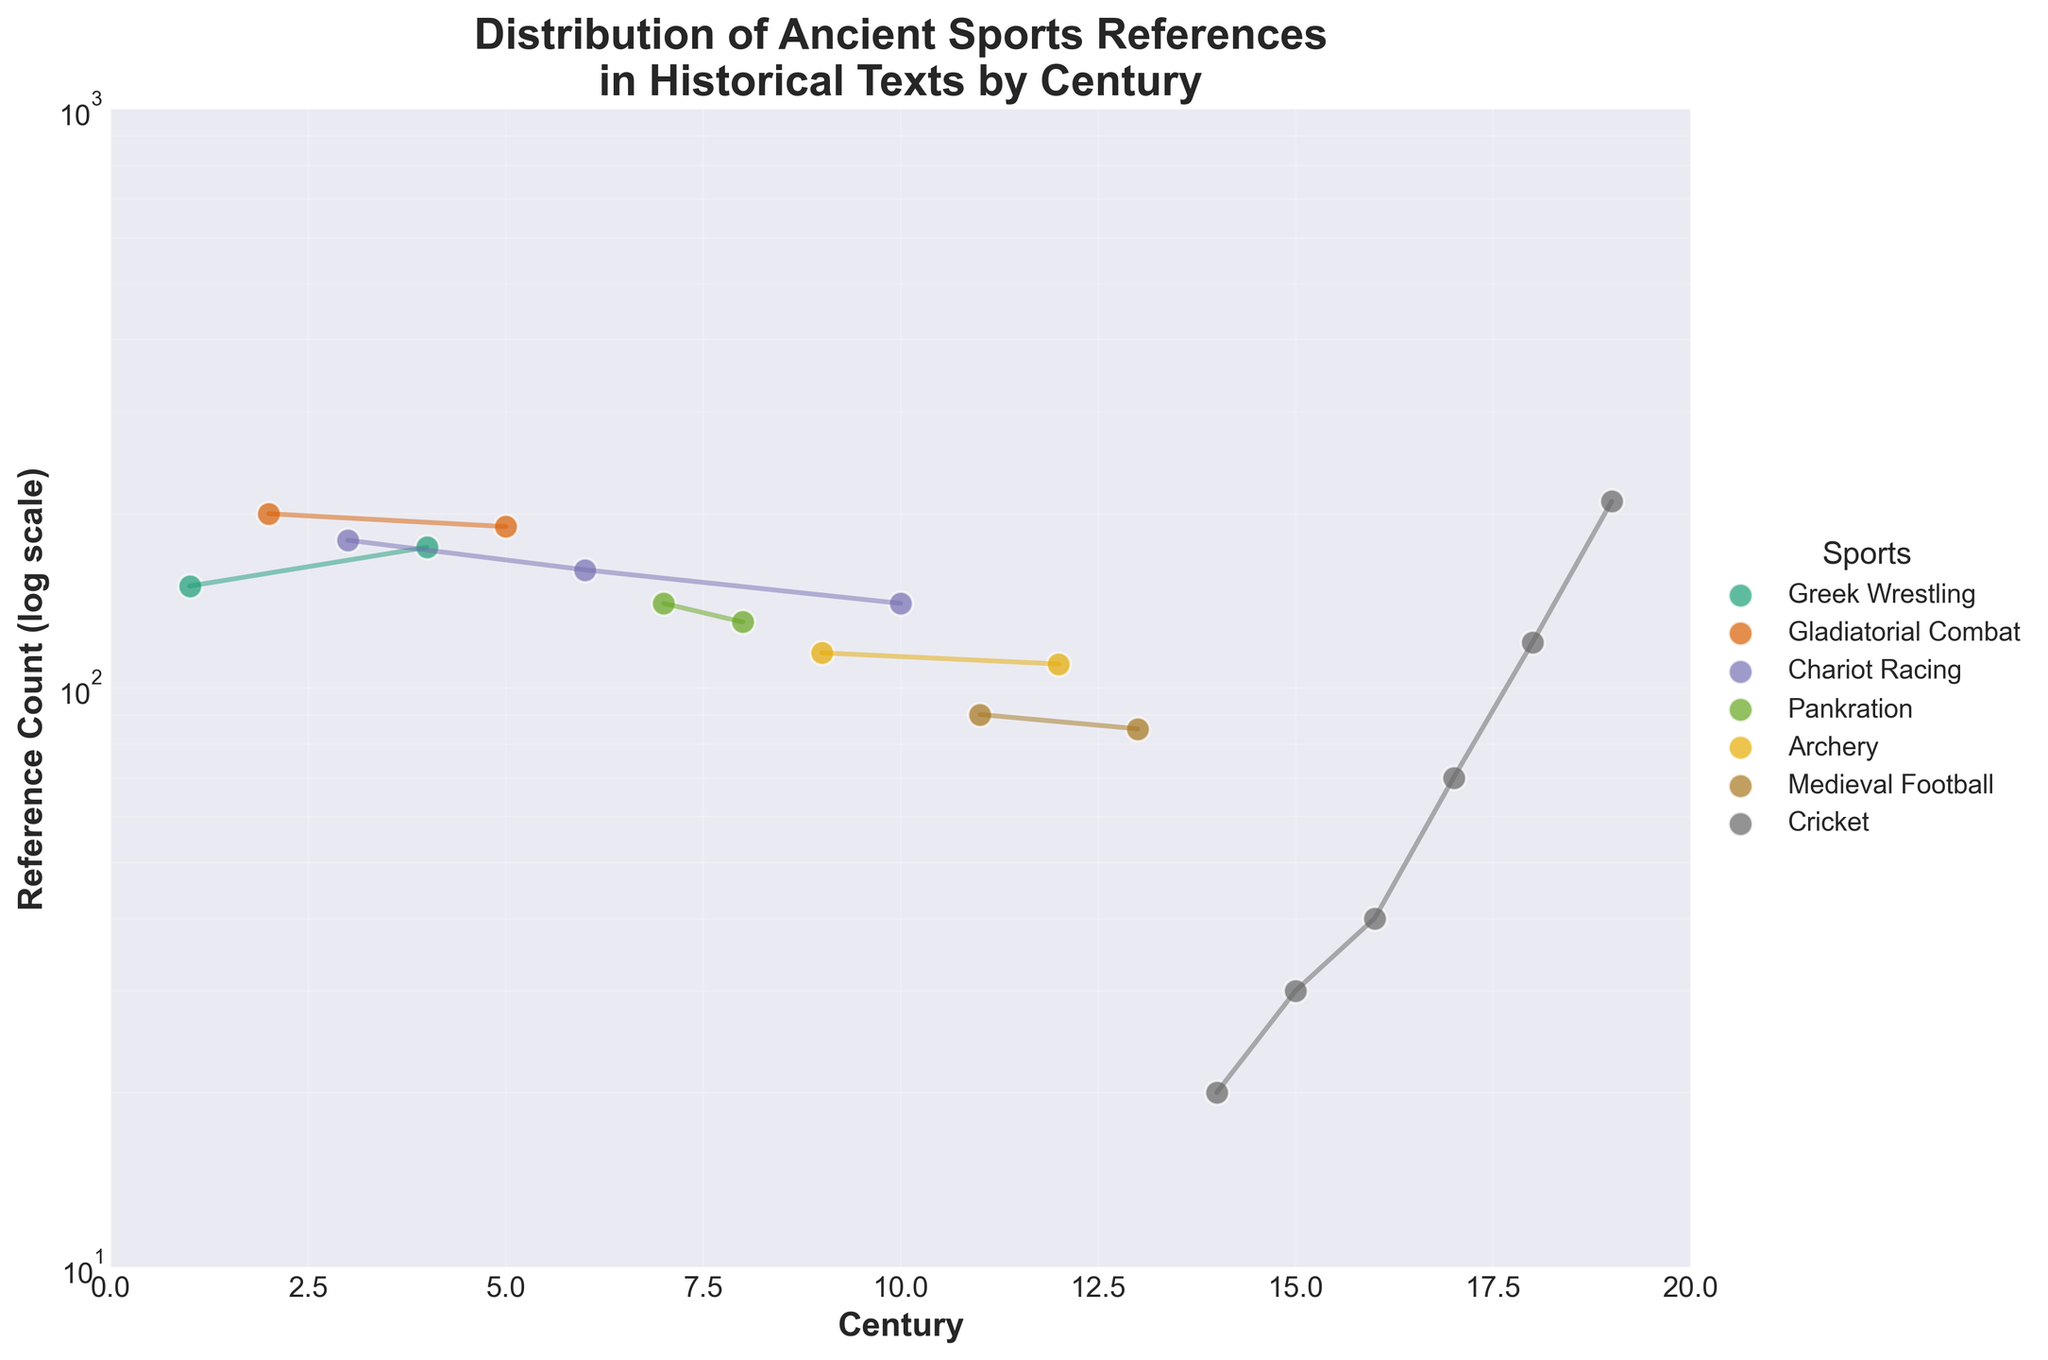How many centuries does the figure cover? The x-axis of the figure shows the range of centuries from 1 to 19, indicating that the figure covers a total span of 19 centuries.
Answer: 19 What is the maximum reference count for any sport in the figure? The y-axis shows reference counts on a log scale, and the highest point on the scale is near 210 in the 19th century for Cricket.
Answer: 210 Which sport has the highest reference count in the 2nd century? By looking or following the trajectory for each sport in the 2nd century, Gladiatorial Combat shows the highest reference count at 200.
Answer: Gladiatorial Combat Between the 5th and 7th centuries, which sport saw a decline in references? By analyzing the lines, Gladiatorial Combat reference count decreased from 190 in the 5th century to 160 in the 6th century.
Answer: Gladiatorial Combat How does the reference count for Cricket change from the 14th to the 19th century? Cricket references increase gradually from 20 in the 14th century to 210 in the 19th century, showing a general upward trend.
Answer: Increases What is the largest drop in reference count between consecutive centuries for any sport? The largest drop appears for Pankration from the 7th to the 8th century, declining from 140 to 130, a drop of 10 references.
Answer: 10 Which sports have steadily increasing reference counts over the centuries? By inspection, Cricket consistently increases its reference counts from the 14th to the 19th century.
Answer: Cricket How many sports are represented in the figure? Observing the unique data points and their labels, there are six distinct sports: Greek Wrestling, Gladiatorial Combat, Chariot Racing, Pankration, Archery, and Cricket.
Answer: 6 In which century does Archery peak in reference count, and what is that count? Archery peaks in the 9th century with a reference count of 115.
Answer: 9th century, 115 Which sport has the least reference count overall, and what is that count? Cricket in the 14th century has the least reference count at 20 among all data points observed.
Answer: Cricket, 20 